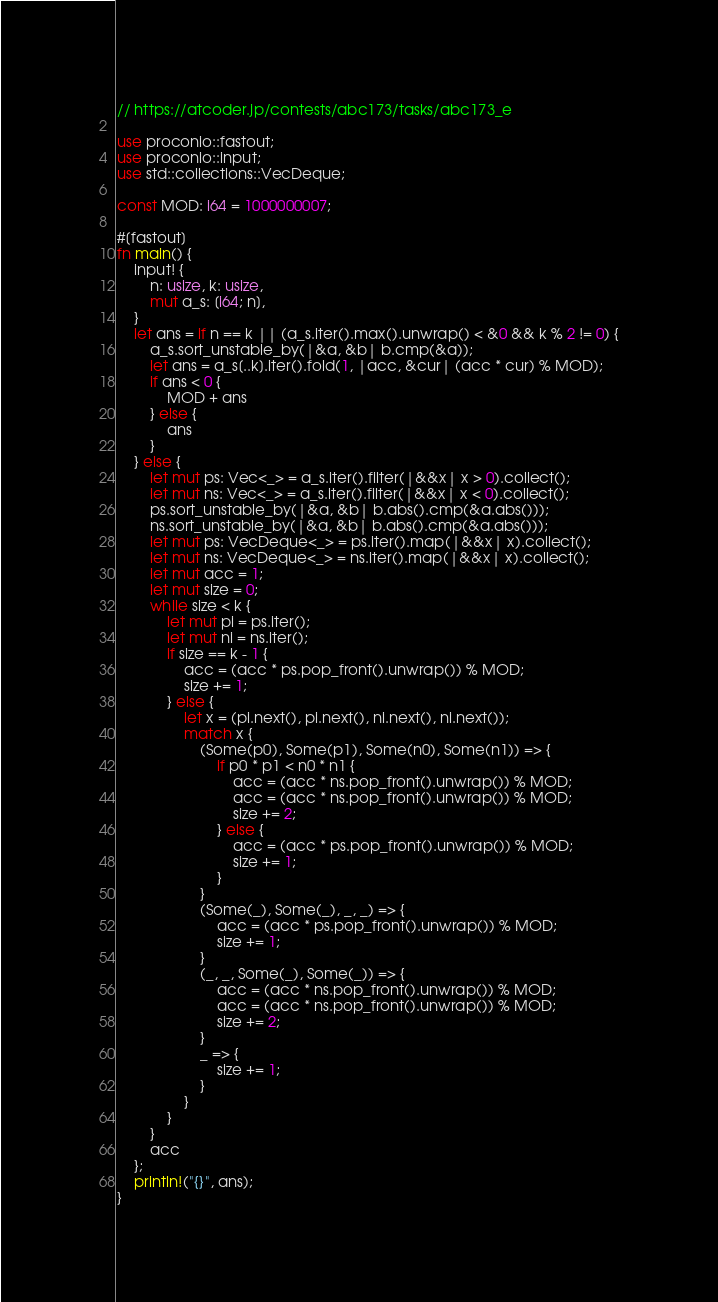Convert code to text. <code><loc_0><loc_0><loc_500><loc_500><_Rust_>// https://atcoder.jp/contests/abc173/tasks/abc173_e

use proconio::fastout;
use proconio::input;
use std::collections::VecDeque;

const MOD: i64 = 1000000007;

#[fastout]
fn main() {
    input! {
        n: usize, k: usize,
        mut a_s: [i64; n],
    }
    let ans = if n == k || (a_s.iter().max().unwrap() < &0 && k % 2 != 0) {
        a_s.sort_unstable_by(|&a, &b| b.cmp(&a));
        let ans = a_s[..k].iter().fold(1, |acc, &cur| (acc * cur) % MOD);
        if ans < 0 {
            MOD + ans
        } else {
            ans
        }
    } else {
        let mut ps: Vec<_> = a_s.iter().filter(|&&x| x > 0).collect();
        let mut ns: Vec<_> = a_s.iter().filter(|&&x| x < 0).collect();
        ps.sort_unstable_by(|&a, &b| b.abs().cmp(&a.abs()));
        ns.sort_unstable_by(|&a, &b| b.abs().cmp(&a.abs()));
        let mut ps: VecDeque<_> = ps.iter().map(|&&x| x).collect();
        let mut ns: VecDeque<_> = ns.iter().map(|&&x| x).collect();
        let mut acc = 1;
        let mut size = 0;
        while size < k {
            let mut pi = ps.iter();
            let mut ni = ns.iter();
            if size == k - 1 {
                acc = (acc * ps.pop_front().unwrap()) % MOD;
                size += 1;
            } else {
                let x = (pi.next(), pi.next(), ni.next(), ni.next());
                match x {
                    (Some(p0), Some(p1), Some(n0), Some(n1)) => {
                        if p0 * p1 < n0 * n1 {
                            acc = (acc * ns.pop_front().unwrap()) % MOD;
                            acc = (acc * ns.pop_front().unwrap()) % MOD;
                            size += 2;
                        } else {
                            acc = (acc * ps.pop_front().unwrap()) % MOD;
                            size += 1;
                        }
                    }
                    (Some(_), Some(_), _, _) => {
                        acc = (acc * ps.pop_front().unwrap()) % MOD;
                        size += 1;
                    }
                    (_, _, Some(_), Some(_)) => {
                        acc = (acc * ns.pop_front().unwrap()) % MOD;
                        acc = (acc * ns.pop_front().unwrap()) % MOD;
                        size += 2;
                    }
                    _ => {
                        size += 1;
                    }
                }
            }
        }
        acc
    };
    println!("{}", ans);
}
</code> 